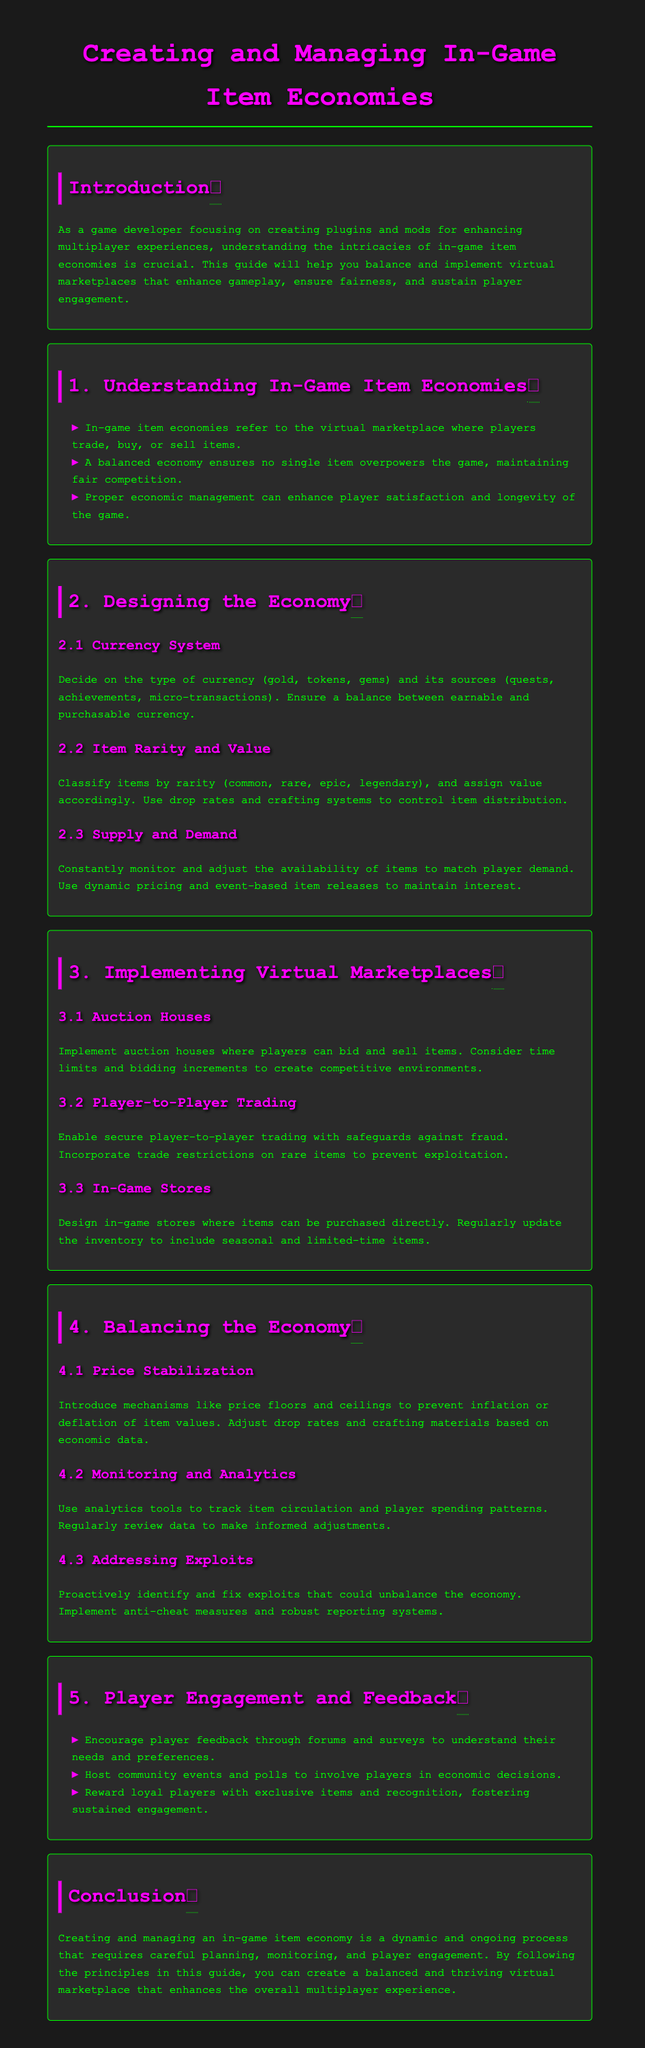What is the title of the guide? The title of the guide is found at the beginning of the document, which introduces the main topic.
Answer: Creating and Managing In-Game Item Economies What are the types of currency mentioned? The document lists different types of currency along with their descriptions in the section about currency systems.
Answer: gold, tokens, gems What classification is used for item rarity? The guide describes a specific classification system for items based on their rarity within the item economy.
Answer: common, rare, epic, legendary What is a method for price stabilization? Methods for stabilizing prices are provided in the economy balancing section, indicating different corrective measures.
Answer: price floors and ceilings How can player engagement be enhanced? The guide suggests various strategies for engaging players and identifies methods for gathering feedback.
Answer: community events and polls What section covers monitoring and analytics? The document clearly outlines which section deals with analytical tools for observing the economy's performance.
Answer: 4.2 Monitoring and Analytics What is a benefit of proper economic management? The advantages of effective economic oversight are mentioned, highlighting the positive outcomes for player experiences.
Answer: player satisfaction What is the main purpose of in-game stores? The document specifies the role of in-game stores in the broader economy management strategy.
Answer: items can be purchased directly 